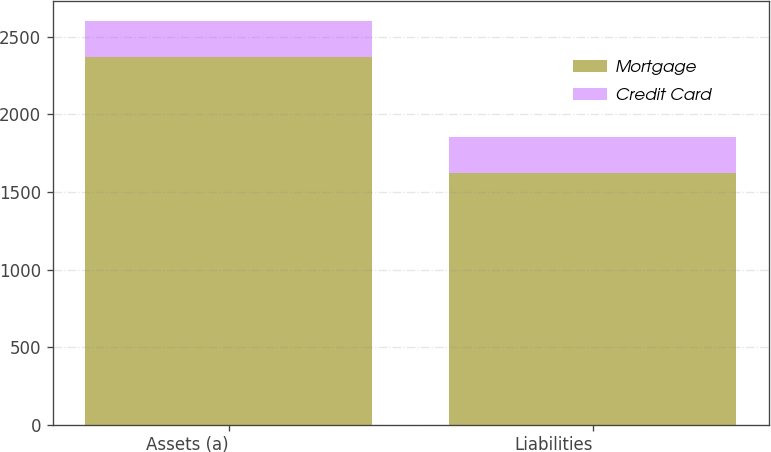Convert chart to OTSL. <chart><loc_0><loc_0><loc_500><loc_500><stacked_bar_chart><ecel><fcel>Assets (a)<fcel>Liabilities<nl><fcel>Mortgage<fcel>2368<fcel>1622<nl><fcel>Credit Card<fcel>232<fcel>232<nl></chart> 